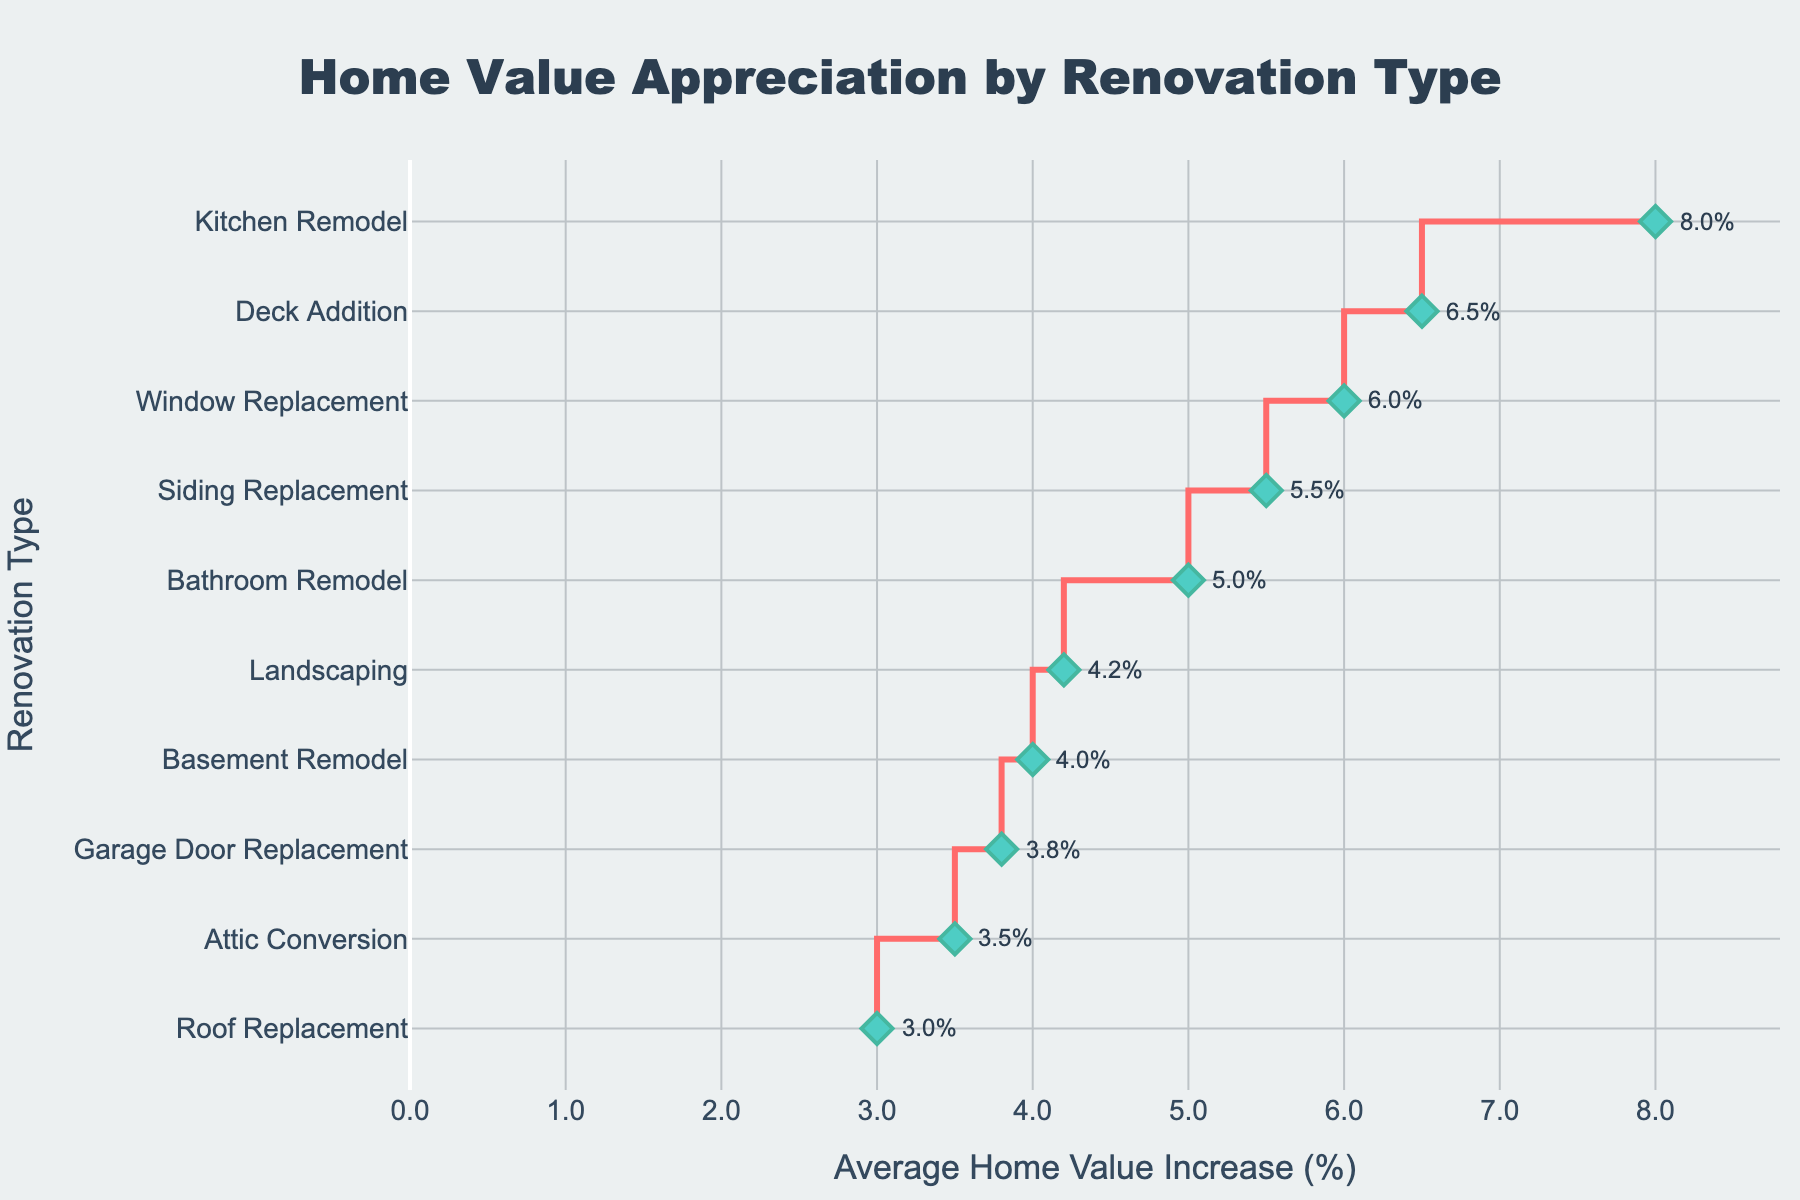What's the title of the plot? The title of the plot is located at the top center and is usually the largest text on the visual. It states the main topic of the visual.
Answer: Home Value Appreciation by Renovation Type What's the average home value increase for a Bathroom Remodel? By looking at the y-axis for "Bathroom Remodel" and the corresponding value on the x-axis, we can determine the increase.
Answer: 5% Which renovation type has the highest home value increase? The highest increase corresponds to the data point farthest to the right on the x-axis. By matching this point with its y-axis label, we identify the renovation type.
Answer: Kitchen Remodel How many renovation types have a home value increase of over 5%? By checking each data point against the 5% mark on the x-axis, we count the types that meet this criterion.
Answer: 4 What's the difference in home value increase between Window Replacement and Roof Replacement? Locate the values for Window Replacement and Roof Replacement, then subtract the smaller percentage from the larger. 6% - 3% = 3%
Answer: 3% Which types of renovations have a home value increase between 4% and 6%? Identify the data points within the 4% to 6% range on the x-axis, then match them to their corresponding y-axis labels.
Answer: Basement Remodel, Landscaping, Siding Replacement, Bathroom Remodel What is the median value increase for all renovation types? Organize all value increases in ascending order: 3%, 3.5%, 3.8%, 4%, 4.2%, 5%, 5.5%, 6%, 6.5%, 8%. The median is the middle value or the average of the two middle values. Here, it’s between 4.2% and 5%. (4.2% + 5%) / 2 = 4.6%
Answer: 4.6% How many renovation types are below 4% in home value increase? Count all renovations corresponding to x-axis values below 4%.
Answer: 3 Between Garage Door Replacement and Deck Addition, which has a higher home value increase? Compare the x-axis positions of Garage Door Replacement and Deck Addition by following their y-axis labels.
Answer: Deck Addition What color are the markers on the plot? By observing the markers in the plot, note their distinct color.
Answer: Turquoise 